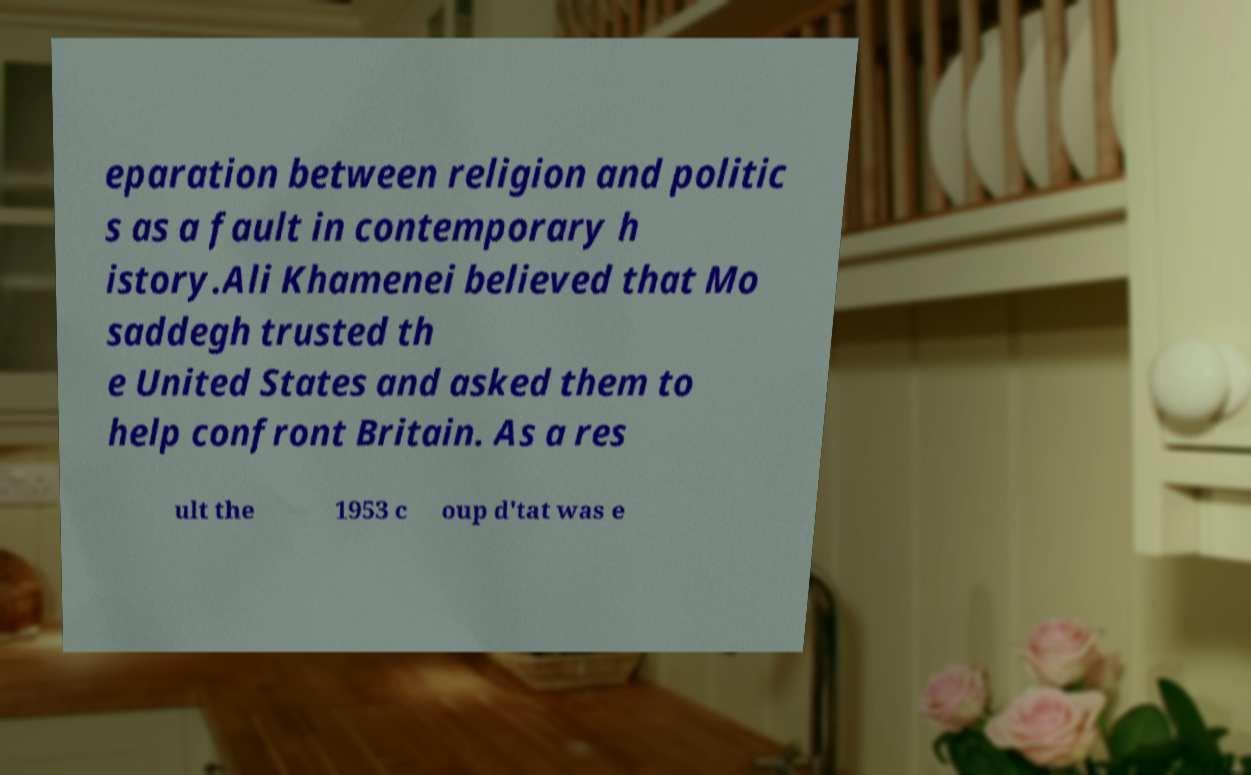Can you read and provide the text displayed in the image?This photo seems to have some interesting text. Can you extract and type it out for me? eparation between religion and politic s as a fault in contemporary h istory.Ali Khamenei believed that Mo saddegh trusted th e United States and asked them to help confront Britain. As a res ult the 1953 c oup d'tat was e 